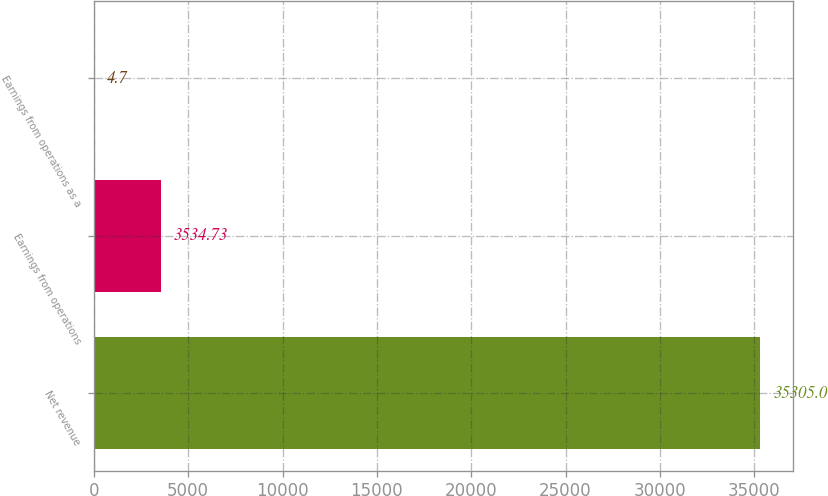Convert chart. <chart><loc_0><loc_0><loc_500><loc_500><bar_chart><fcel>Net revenue<fcel>Earnings from operations<fcel>Earnings from operations as a<nl><fcel>35305<fcel>3534.73<fcel>4.7<nl></chart> 